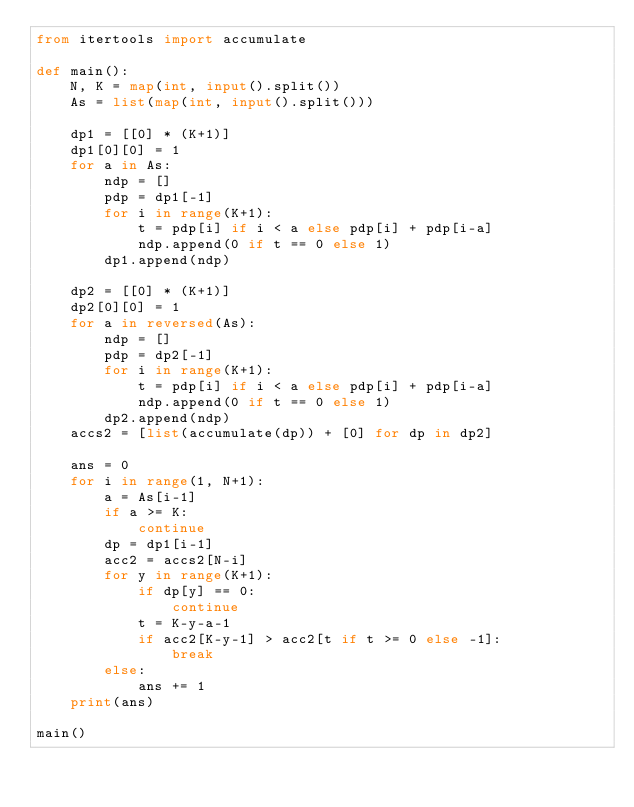<code> <loc_0><loc_0><loc_500><loc_500><_Python_>from itertools import accumulate

def main():
    N, K = map(int, input().split())
    As = list(map(int, input().split()))
    
    dp1 = [[0] * (K+1)]
    dp1[0][0] = 1
    for a in As:
        ndp = []
        pdp = dp1[-1]
        for i in range(K+1):
            t = pdp[i] if i < a else pdp[i] + pdp[i-a]
            ndp.append(0 if t == 0 else 1)
        dp1.append(ndp)
    
    dp2 = [[0] * (K+1)]
    dp2[0][0] = 1
    for a in reversed(As):
        ndp = []
        pdp = dp2[-1]
        for i in range(K+1):
            t = pdp[i] if i < a else pdp[i] + pdp[i-a]
            ndp.append(0 if t == 0 else 1)
        dp2.append(ndp)
    accs2 = [list(accumulate(dp)) + [0] for dp in dp2]
    
    ans = 0
    for i in range(1, N+1):
        a = As[i-1]
        if a >= K:
            continue
        dp = dp1[i-1]
        acc2 = accs2[N-i]
        for y in range(K+1):
            if dp[y] == 0:
                continue
            t = K-y-a-1
            if acc2[K-y-1] > acc2[t if t >= 0 else -1]:
                break
        else:
            ans += 1
    print(ans)

main()
</code> 